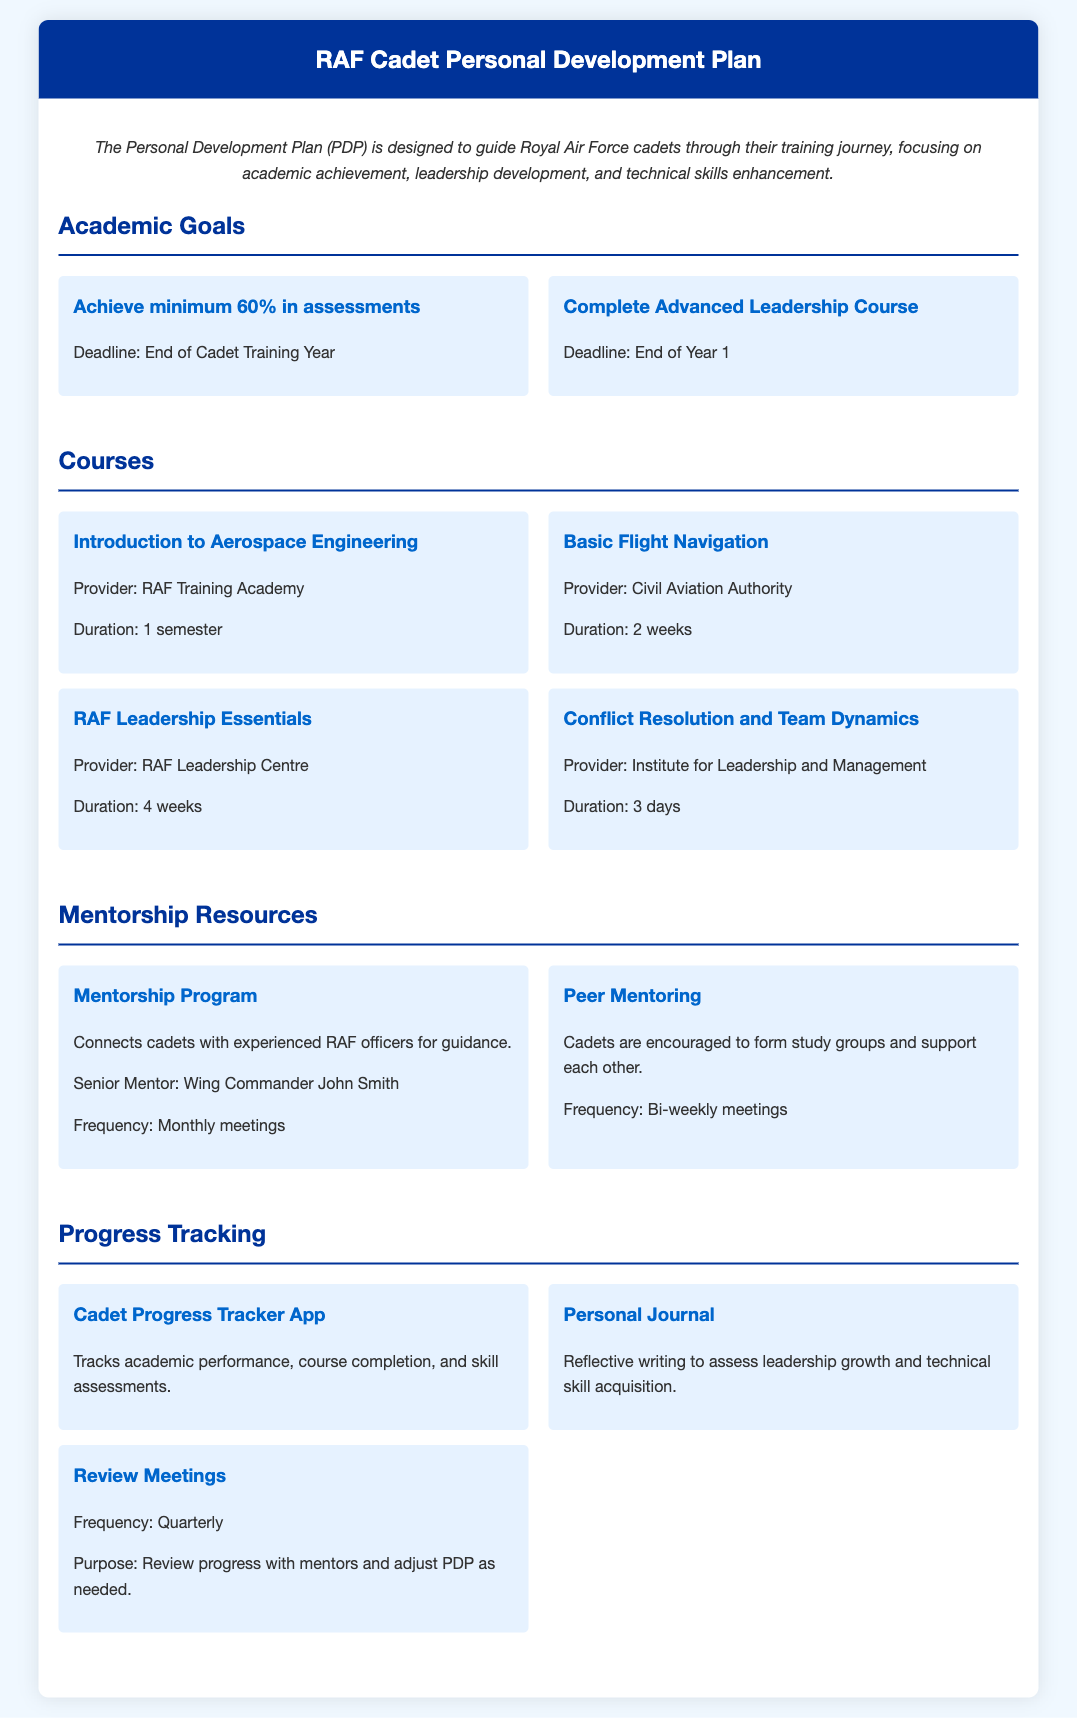What is the minimum percentage required in assessments? The document states that cadets must achieve a minimum of 60% in assessments.
Answer: 60% Who is the Senior Mentor in the Mentorship Program? The document mentions Wing Commander John Smith as the Senior Mentor.
Answer: Wing Commander John Smith What is the duration of the RAF Leadership Essentials course? The document lists the duration of the RAF Leadership Essentials course as 4 weeks.
Answer: 4 weeks How often do Review Meetings occur? The document specifies that Review Meetings occur quarterly.
Answer: Quarterly What is the provider of the course "Introduction to Aerospace Engineering"? The document indicates that the provider for this course is the RAF Training Academy.
Answer: RAF Training Academy What type of writing is included in the Personal Journal? The document describes the Personal Journal as involving reflective writing.
Answer: Reflective writing What is one goal to be achieved by the end of Year 1? The document states that completing the Advanced Leadership Course is a goal by the end of Year 1.
Answer: Complete Advanced Leadership Course How frequently do Peer Mentoring meetings occur? According to the document, Peer Mentoring meetings occur bi-weekly.
Answer: Bi-weekly 